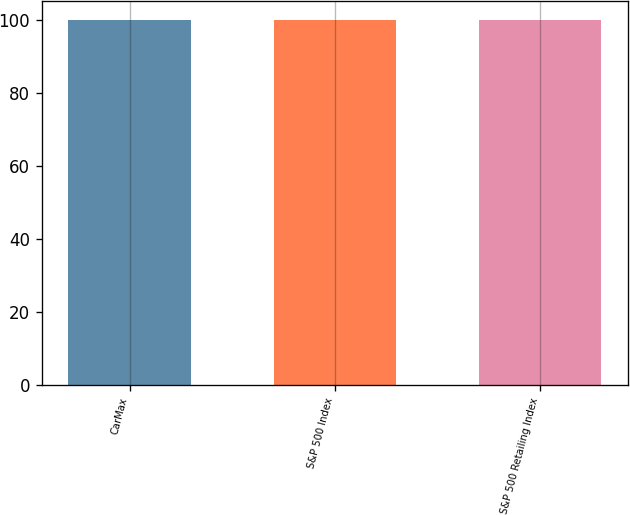<chart> <loc_0><loc_0><loc_500><loc_500><bar_chart><fcel>CarMax<fcel>S&P 500 Index<fcel>S&P 500 Retailing Index<nl><fcel>100<fcel>100.1<fcel>100.2<nl></chart> 